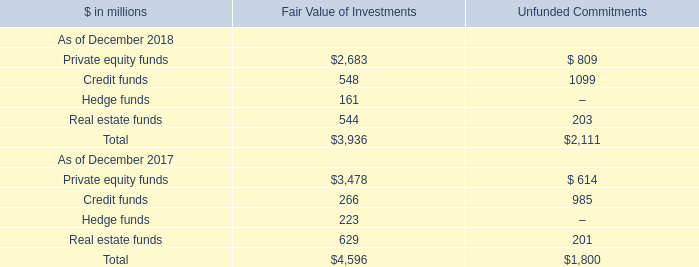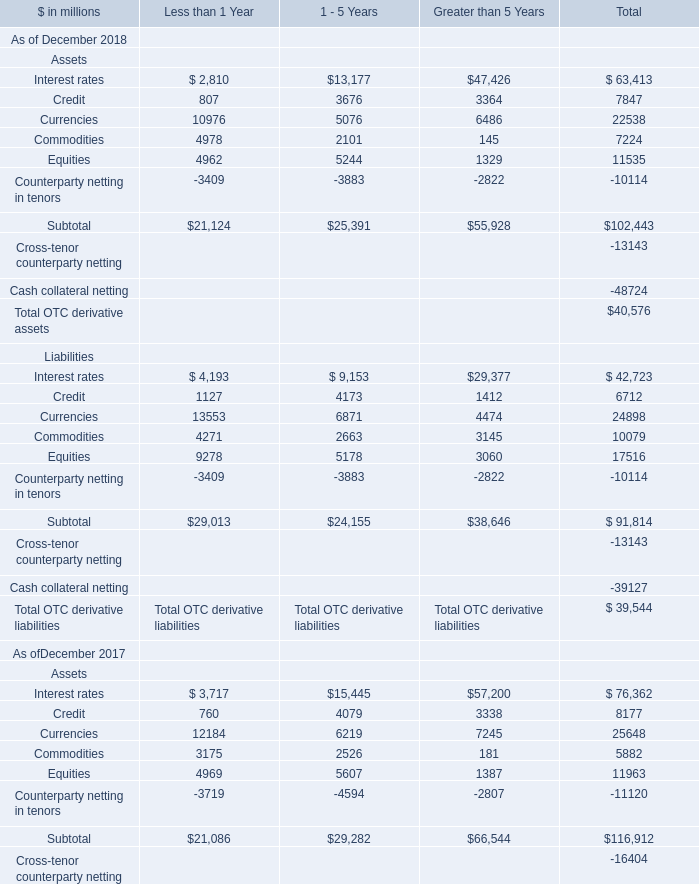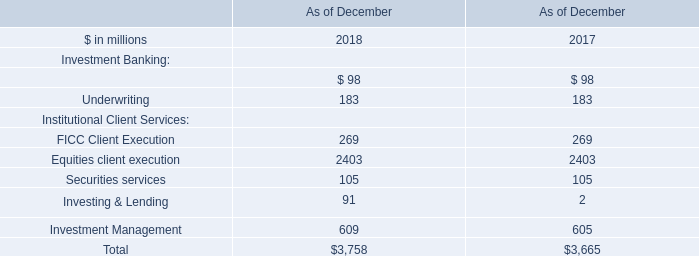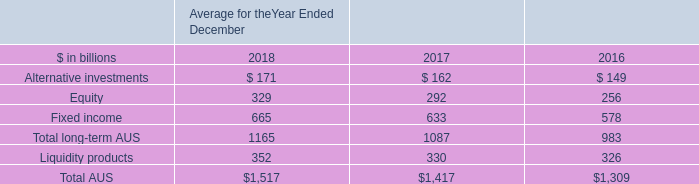In the year with the greatest proportion of Credit for assets in total, what is the proportion of Credit for assets in total to the total? (in %) 
Computations: (7847 / 102443)
Answer: 0.0766. 